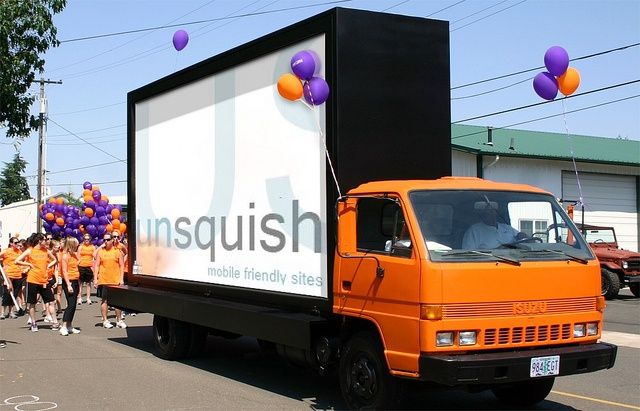Describe the objects in this image and their specific colors. I can see truck in darkgreen, black, red, brown, and orange tones, car in darkgreen, black, ivory, maroon, and gray tones, truck in darkgreen, black, ivory, maroon, and gray tones, people in darkgreen, black, orange, and tan tones, and people in darkgreen, orange, salmon, and gold tones in this image. 